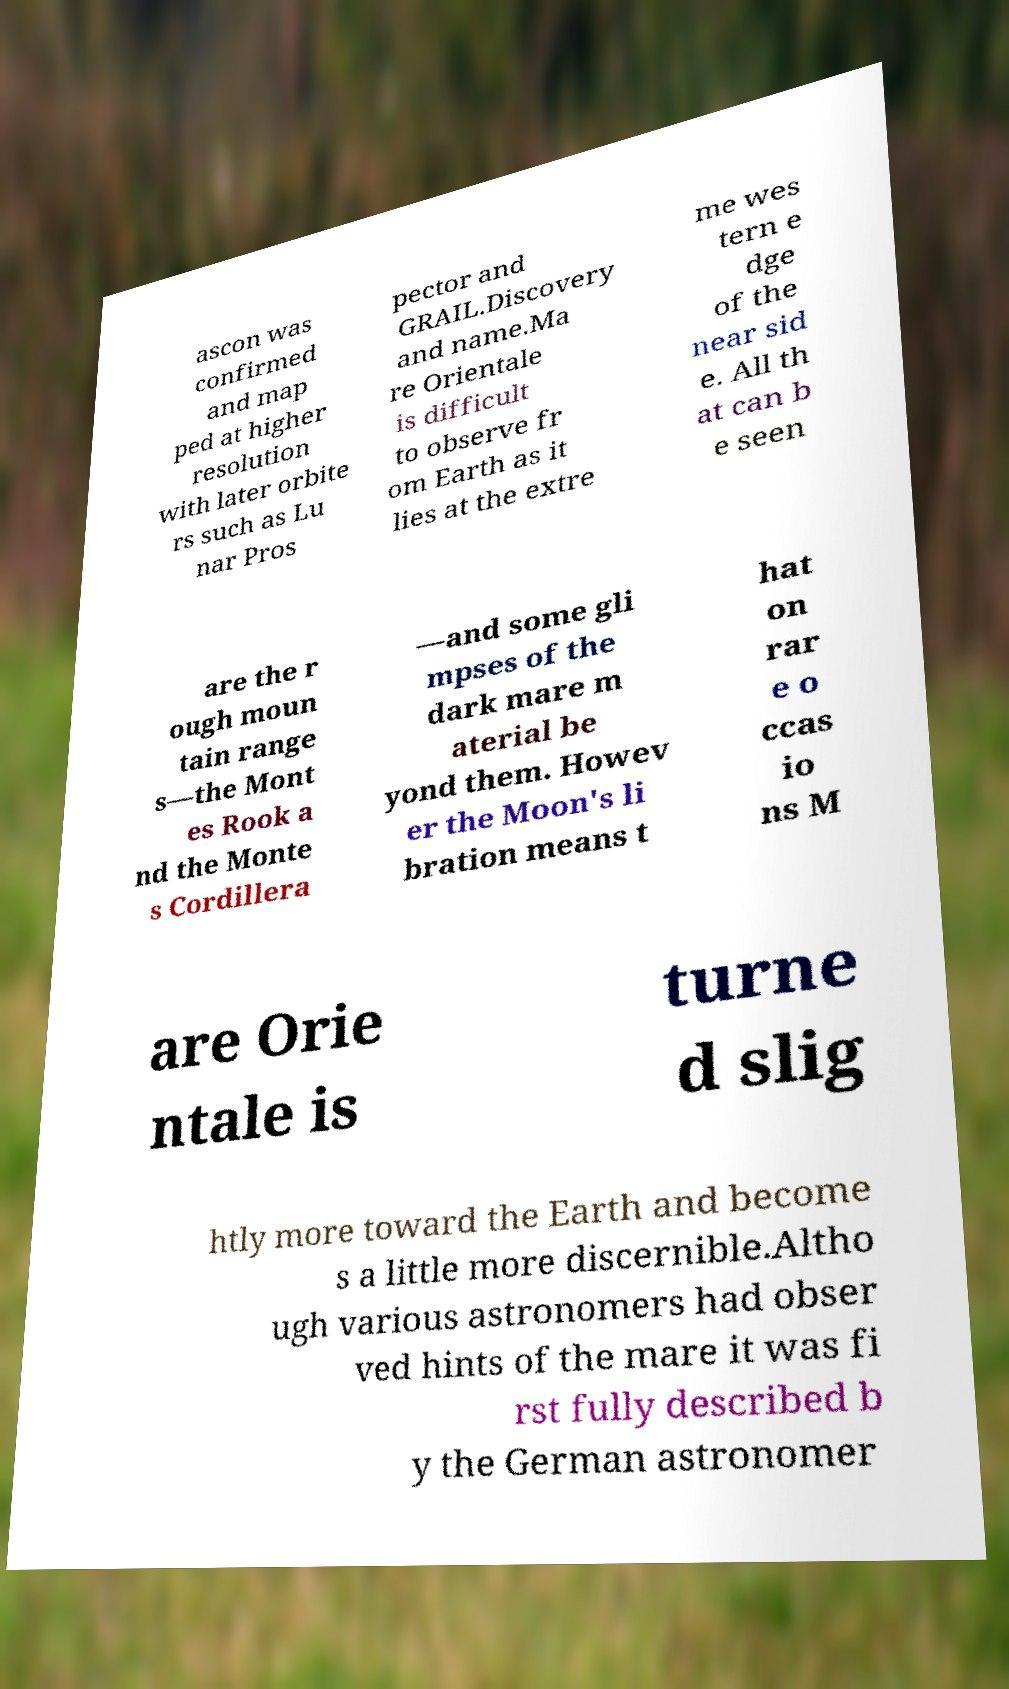I need the written content from this picture converted into text. Can you do that? ascon was confirmed and map ped at higher resolution with later orbite rs such as Lu nar Pros pector and GRAIL.Discovery and name.Ma re Orientale is difficult to observe fr om Earth as it lies at the extre me wes tern e dge of the near sid e. All th at can b e seen are the r ough moun tain range s—the Mont es Rook a nd the Monte s Cordillera —and some gli mpses of the dark mare m aterial be yond them. Howev er the Moon's li bration means t hat on rar e o ccas io ns M are Orie ntale is turne d slig htly more toward the Earth and become s a little more discernible.Altho ugh various astronomers had obser ved hints of the mare it was fi rst fully described b y the German astronomer 